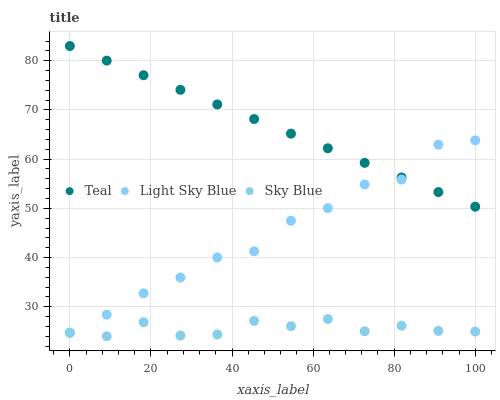Does Sky Blue have the minimum area under the curve?
Answer yes or no. Yes. Does Teal have the maximum area under the curve?
Answer yes or no. Yes. Does Light Sky Blue have the minimum area under the curve?
Answer yes or no. No. Does Light Sky Blue have the maximum area under the curve?
Answer yes or no. No. Is Teal the smoothest?
Answer yes or no. Yes. Is Light Sky Blue the roughest?
Answer yes or no. Yes. Is Light Sky Blue the smoothest?
Answer yes or no. No. Is Teal the roughest?
Answer yes or no. No. Does Sky Blue have the lowest value?
Answer yes or no. Yes. Does Light Sky Blue have the lowest value?
Answer yes or no. No. Does Teal have the highest value?
Answer yes or no. Yes. Does Light Sky Blue have the highest value?
Answer yes or no. No. Is Sky Blue less than Teal?
Answer yes or no. Yes. Is Light Sky Blue greater than Sky Blue?
Answer yes or no. Yes. Does Light Sky Blue intersect Teal?
Answer yes or no. Yes. Is Light Sky Blue less than Teal?
Answer yes or no. No. Is Light Sky Blue greater than Teal?
Answer yes or no. No. Does Sky Blue intersect Teal?
Answer yes or no. No. 